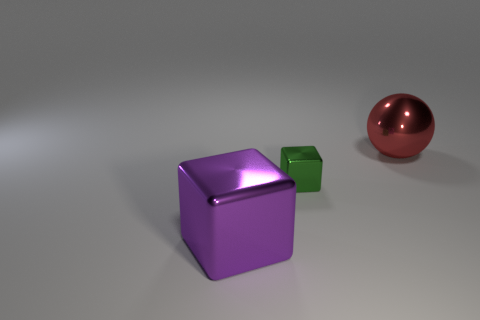What is the color of the big object that is behind the purple thing? The large object situated behind the purple cube is a sphere with a reflective red surface that catches the light beautifully. 